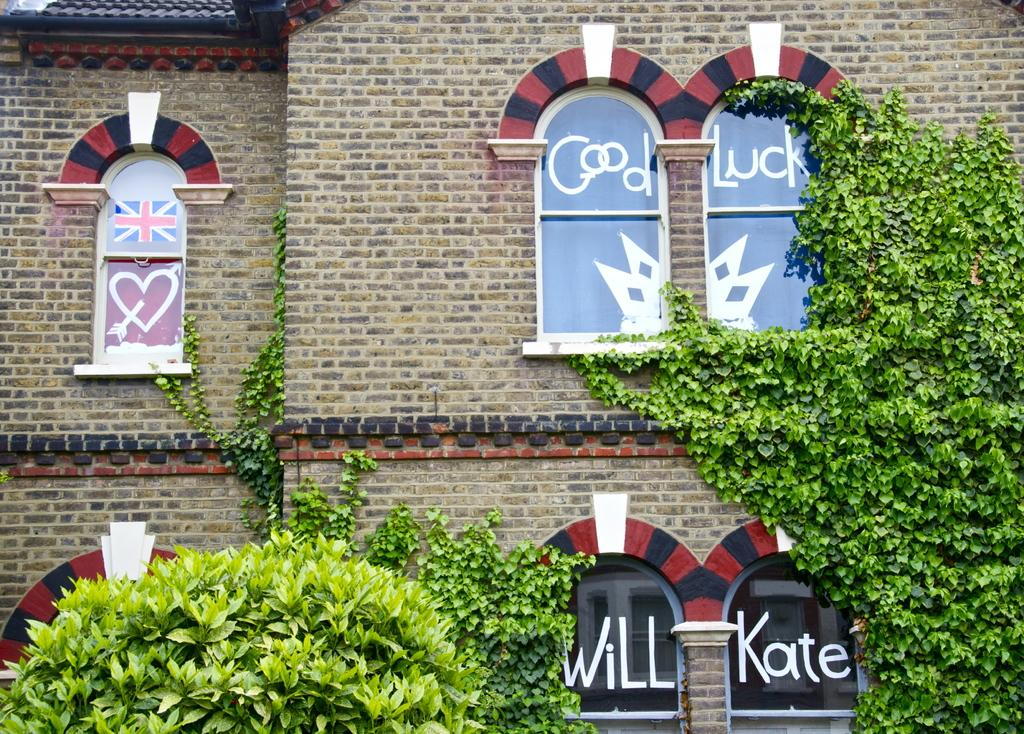What type of vegetation is present in the image? There are green leaves in the image. What type of structure is visible in the image? There is a building in the image. What architectural feature can be seen on the building? There are windows in the image. What is attached to the windows in the image? There is a flag and a poster on the windows in the image. What is written or visible on the windows in the image? There is some text visible on the windows in the image. What type of soda is being advertised on the poster in the image? There is no soda or advertisement present in the image. What is the belief system of the people in the image? The image does not provide any information about the belief system of the people in the image. 